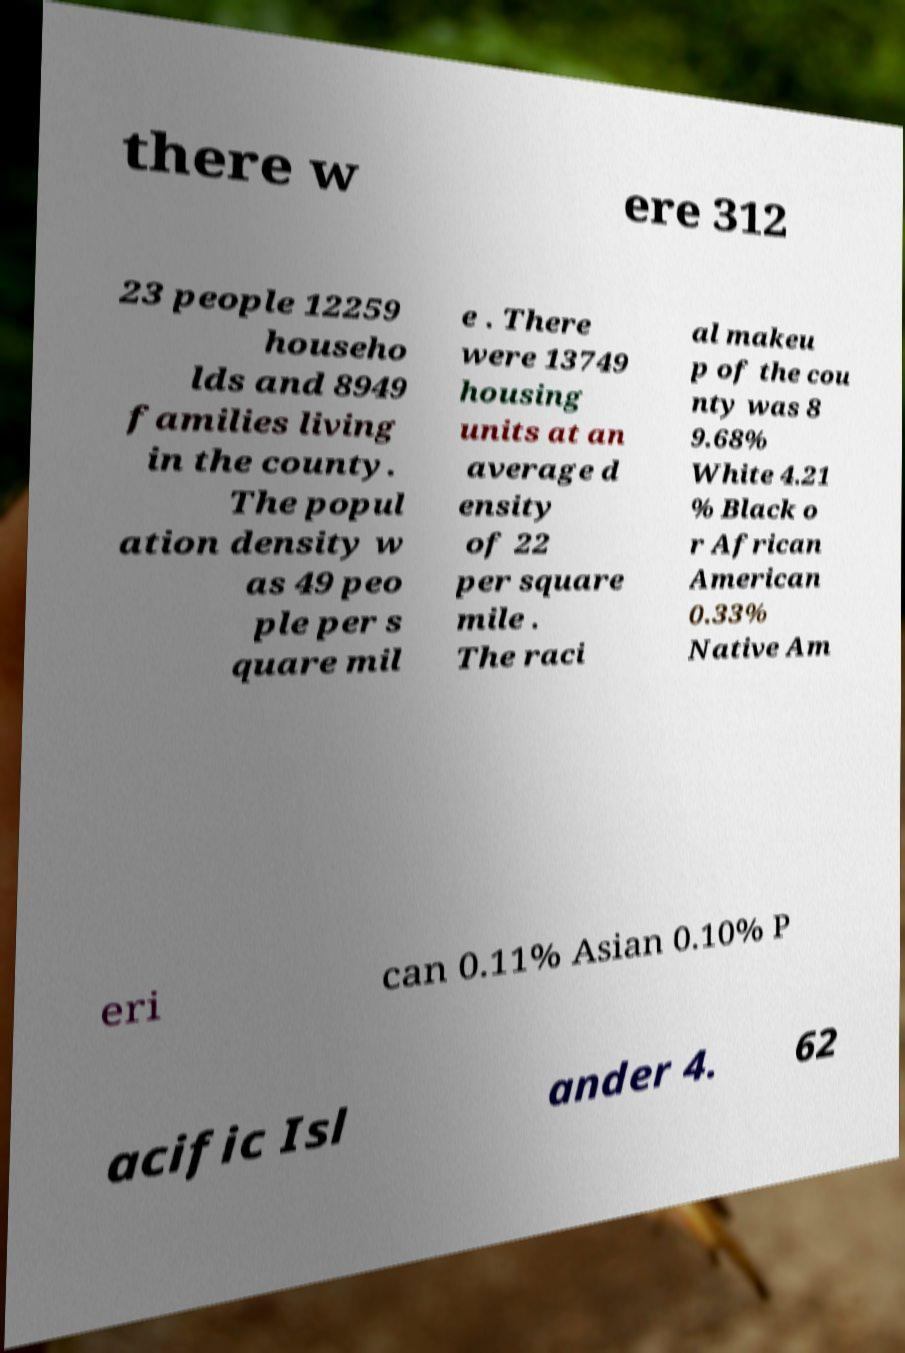Can you read and provide the text displayed in the image?This photo seems to have some interesting text. Can you extract and type it out for me? there w ere 312 23 people 12259 househo lds and 8949 families living in the county. The popul ation density w as 49 peo ple per s quare mil e . There were 13749 housing units at an average d ensity of 22 per square mile . The raci al makeu p of the cou nty was 8 9.68% White 4.21 % Black o r African American 0.33% Native Am eri can 0.11% Asian 0.10% P acific Isl ander 4. 62 